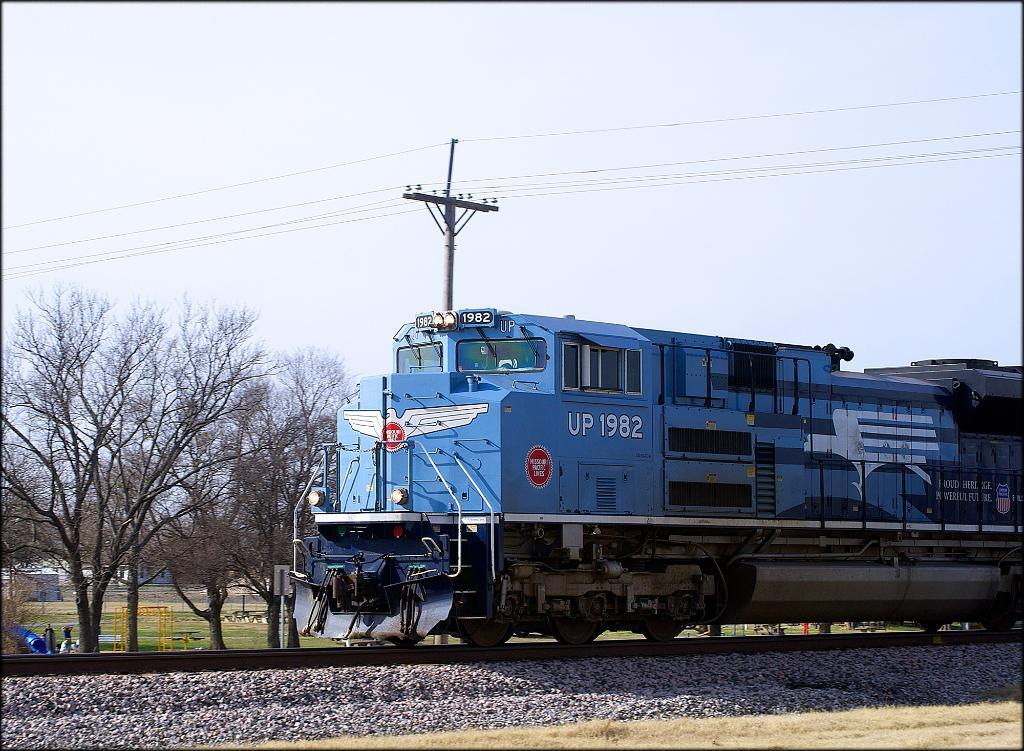<image>
Provide a brief description of the given image. A blue train that says UP 1982 is going down a track under a power line. 